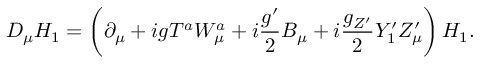<formula> <loc_0><loc_0><loc_500><loc_500>D _ { \mu } H _ { 1 } = \left ( \partial _ { \mu } + i g T ^ { a } W _ { \mu } ^ { a } + i \frac { g ^ { \prime } } { 2 } B _ { \mu } + i \frac { g _ { Z ^ { \prime } } } { 2 } Y _ { 1 } ^ { \prime } Z _ { \mu } ^ { \prime } \right ) H _ { 1 } .</formula> 